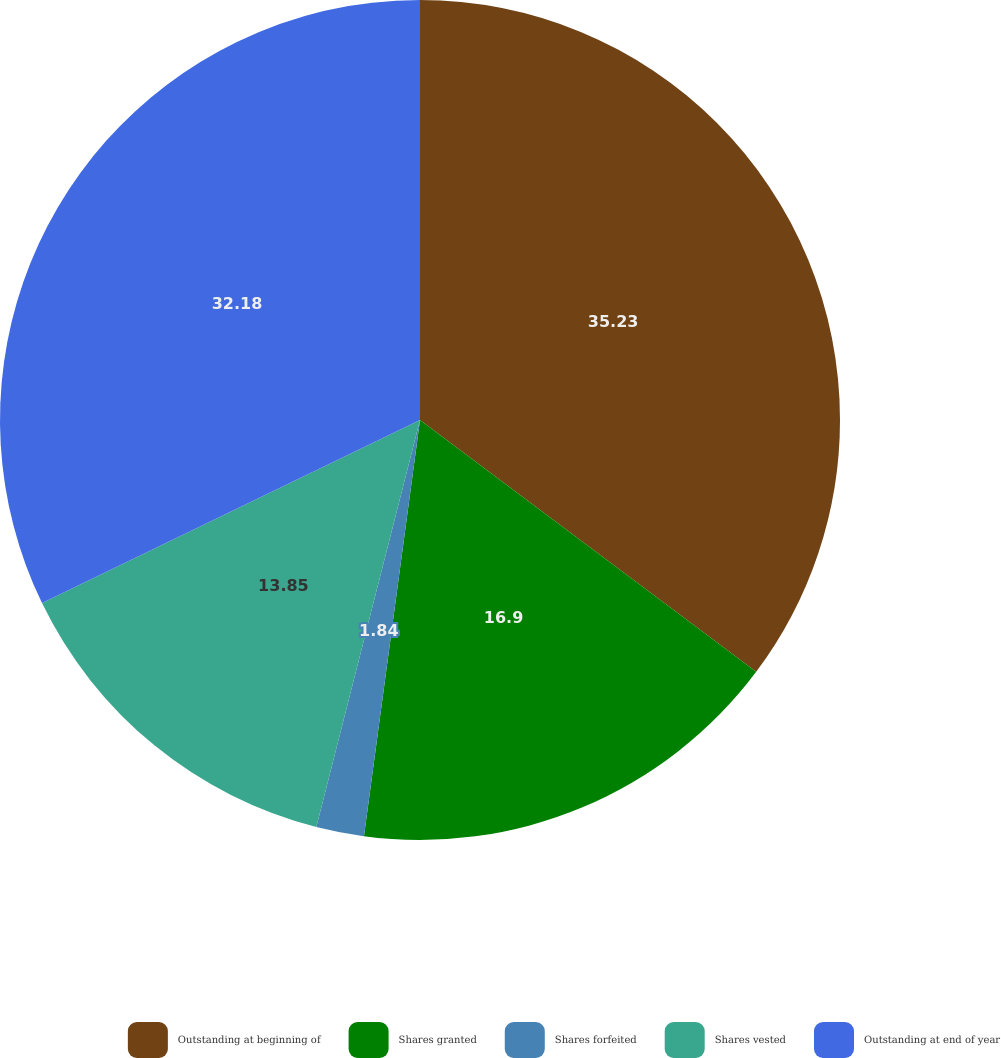Convert chart. <chart><loc_0><loc_0><loc_500><loc_500><pie_chart><fcel>Outstanding at beginning of<fcel>Shares granted<fcel>Shares forfeited<fcel>Shares vested<fcel>Outstanding at end of year<nl><fcel>35.23%<fcel>16.9%<fcel>1.84%<fcel>13.85%<fcel>32.18%<nl></chart> 